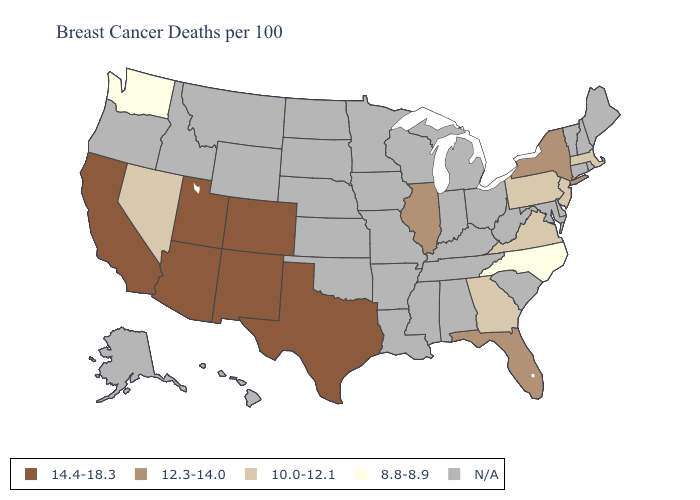Among the states that border California , which have the lowest value?
Give a very brief answer. Nevada. Which states hav the highest value in the Northeast?
Be succinct. New York. Name the states that have a value in the range 12.3-14.0?
Give a very brief answer. Florida, Illinois, New York. Does North Carolina have the lowest value in the South?
Answer briefly. Yes. What is the value of Nevada?
Concise answer only. 10.0-12.1. Which states have the lowest value in the USA?
Give a very brief answer. North Carolina, Washington. Is the legend a continuous bar?
Quick response, please. No. Name the states that have a value in the range 10.0-12.1?
Give a very brief answer. Georgia, Massachusetts, Nevada, New Jersey, Pennsylvania, Virginia. What is the value of Hawaii?
Concise answer only. N/A. What is the value of Illinois?
Answer briefly. 12.3-14.0. Does Georgia have the highest value in the South?
Short answer required. No. 